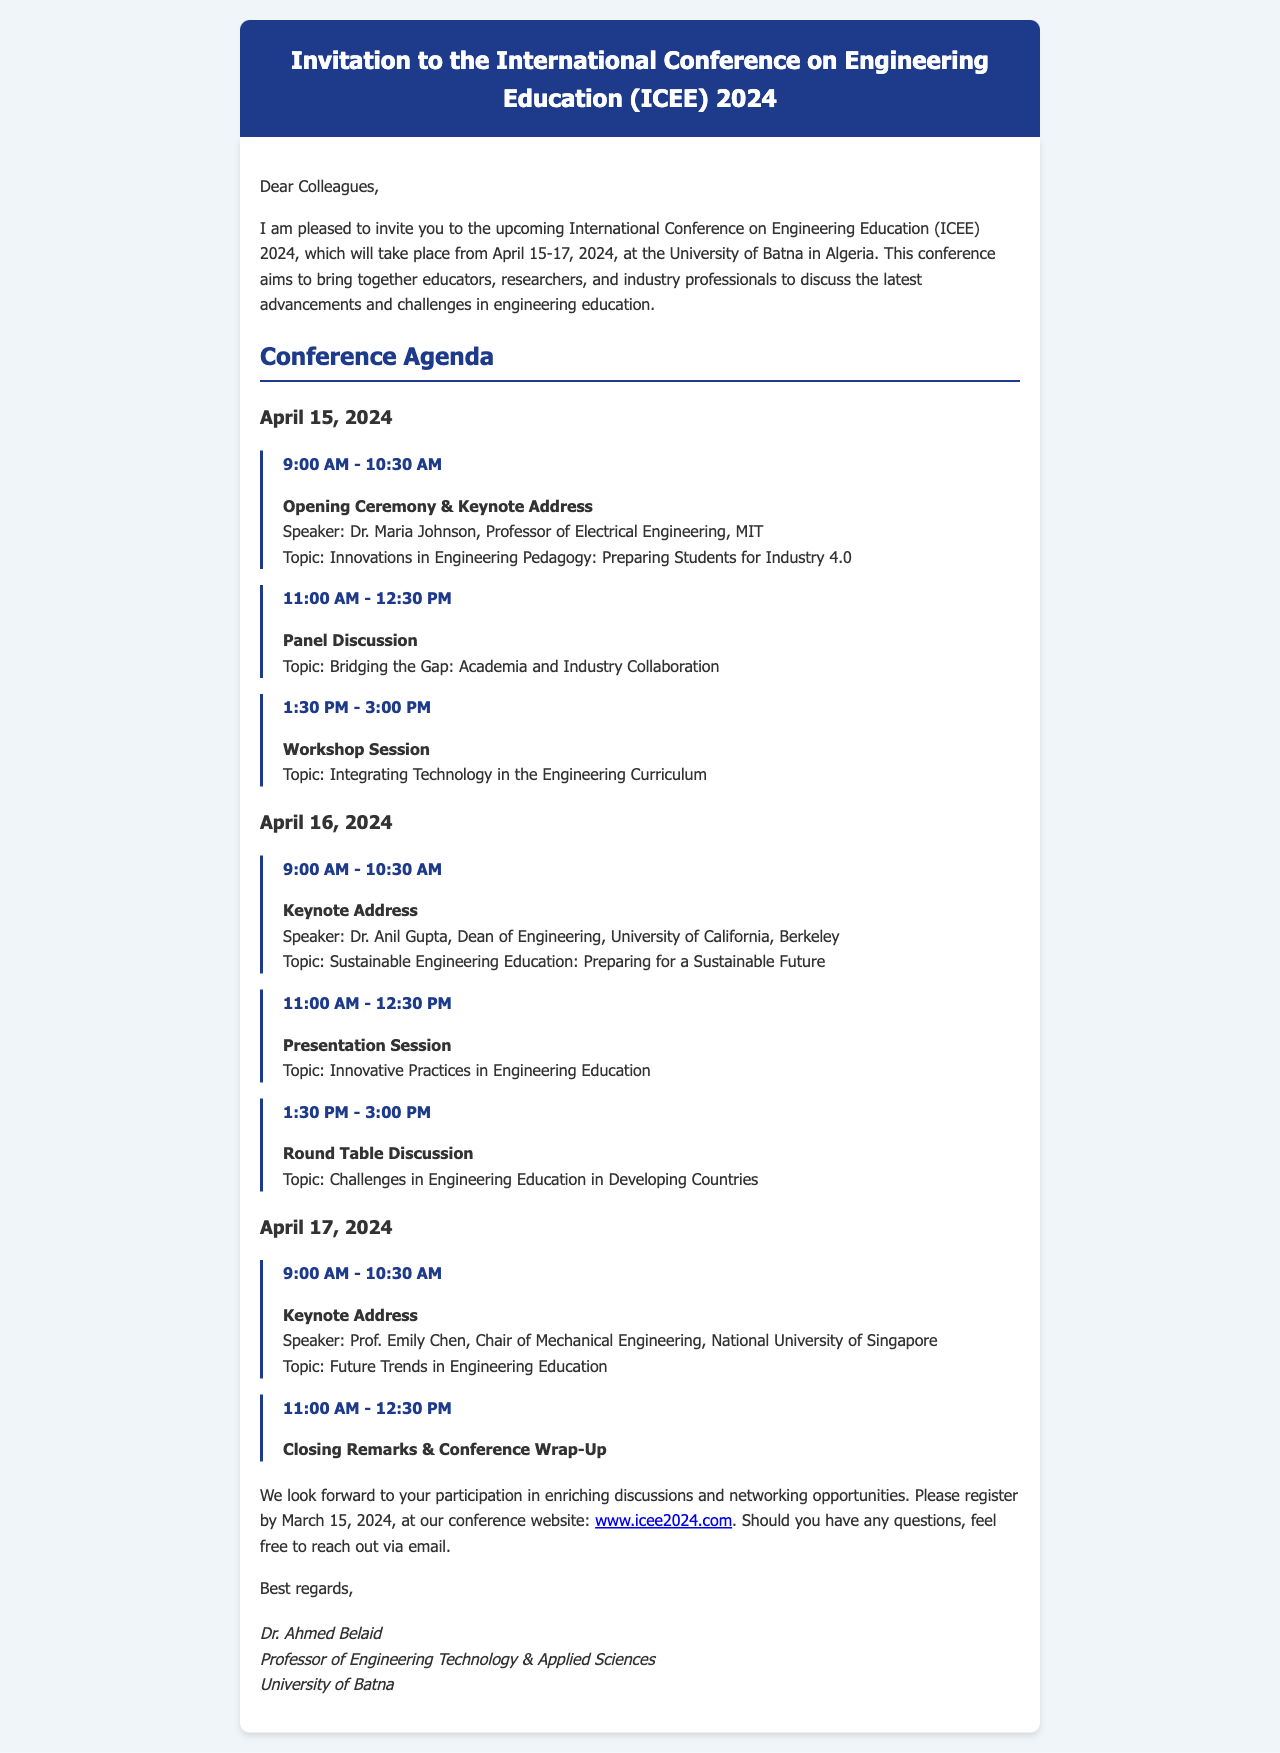What are the dates of the conference? The conference will take place from April 15-17, 2024.
Answer: April 15-17, 2024 Who is the first keynote speaker? The first keynote speaker is Dr. Maria Johnson, who opens the conference.
Answer: Dr. Maria Johnson What is the topic of the keynote address on April 16? The topic of the keynote address on April 16 is about sustainable engineering education.
Answer: Sustainable Engineering Education: Preparing for a Sustainable Future When is the registration deadline? The deadline for registration is mentioned in the document, and it states March 15, 2024.
Answer: March 15, 2024 How many days will the conference run? The document provides details on the conference spanning three specific dates.
Answer: Three days What will be discussed in the panel discussion? The panel discussion is focused on bridging the gaps between academia and industry.
Answer: Bridging the Gap: Academia and Industry Collaboration Who will deliver the closing remarks? The document does not specify a name for the closing remarks, but it states it will be part of the conference wrap-up.
Answer: Not specified What is the website for registration? The document includes a link for registration that is specifically cited.
Answer: www.icee2024.com What is the location of the conference? The conference is hosted at the University of Batna in Algeria.
Answer: University of Batna in Algeria 